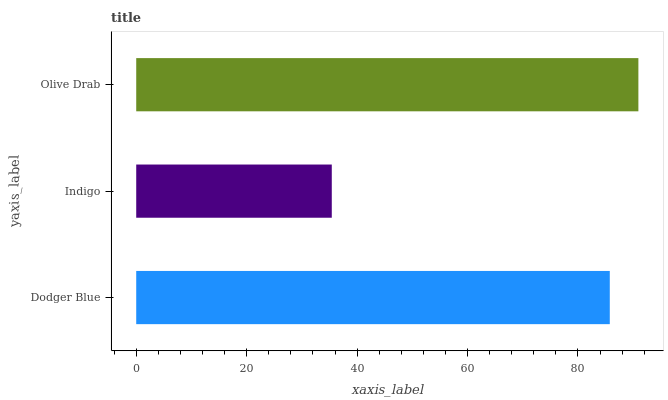Is Indigo the minimum?
Answer yes or no. Yes. Is Olive Drab the maximum?
Answer yes or no. Yes. Is Olive Drab the minimum?
Answer yes or no. No. Is Indigo the maximum?
Answer yes or no. No. Is Olive Drab greater than Indigo?
Answer yes or no. Yes. Is Indigo less than Olive Drab?
Answer yes or no. Yes. Is Indigo greater than Olive Drab?
Answer yes or no. No. Is Olive Drab less than Indigo?
Answer yes or no. No. Is Dodger Blue the high median?
Answer yes or no. Yes. Is Dodger Blue the low median?
Answer yes or no. Yes. Is Olive Drab the high median?
Answer yes or no. No. Is Indigo the low median?
Answer yes or no. No. 